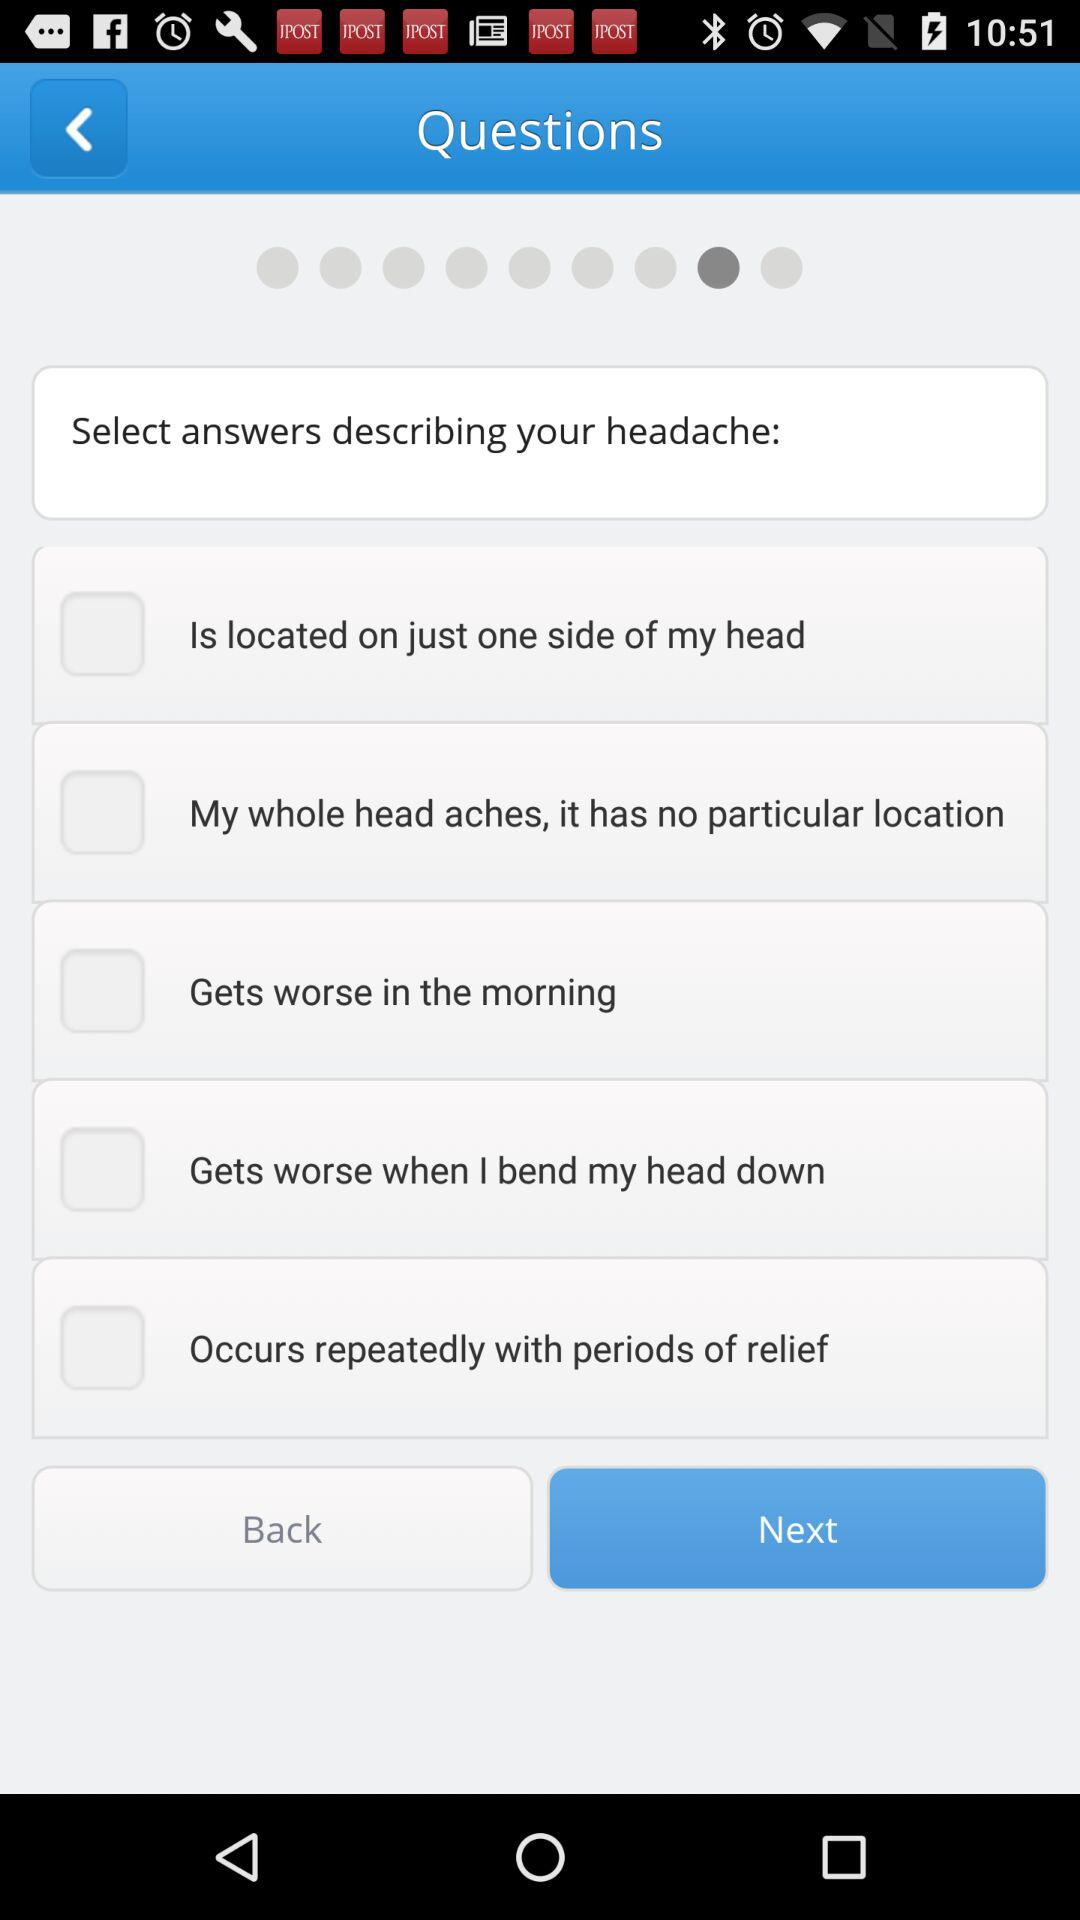What are the available options? The available options are "Is located on just one side of my head", "My whole head aches, it has no particular location", "Gets worse in the morning", "Gets worse when I blend my head down" and "Occurs repeatedly with periods of relief". 